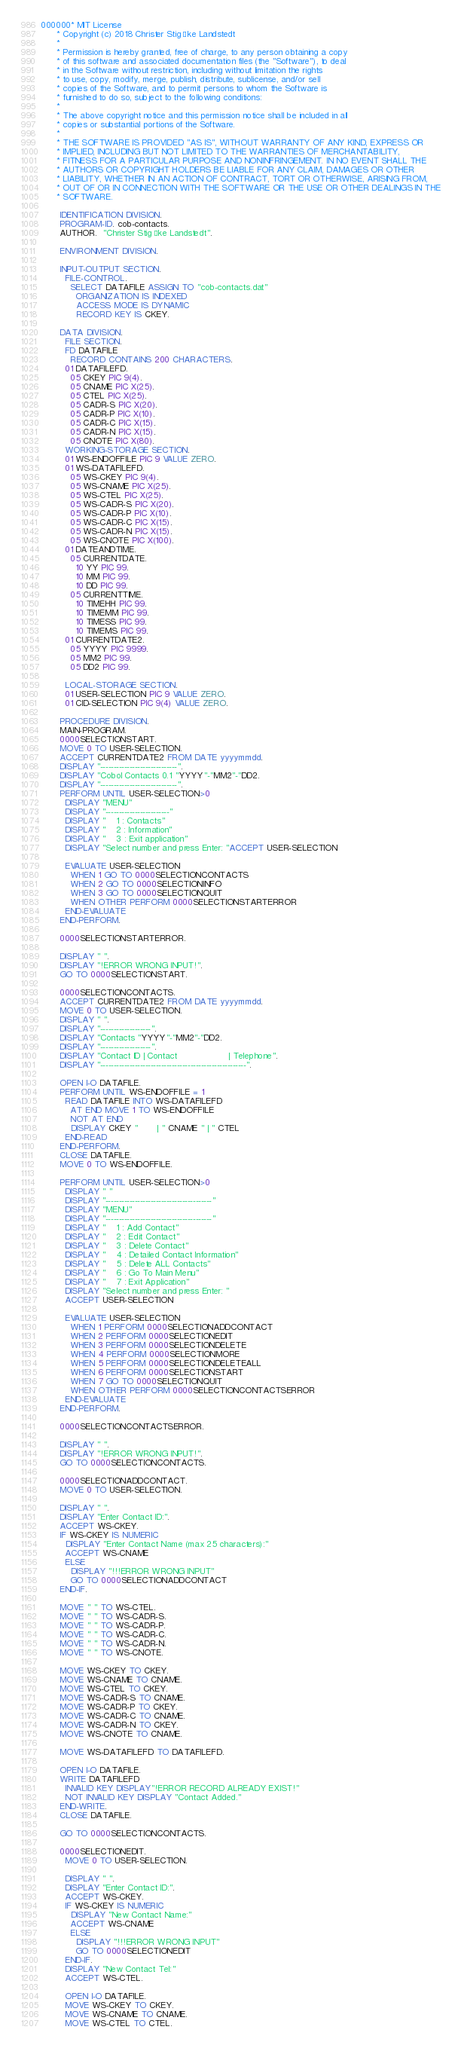Convert code to text. <code><loc_0><loc_0><loc_500><loc_500><_COBOL_>000000* MIT License
      * Copyright (c) 2018 Christer Stig Åke Landstedt
      * 
      * Permission is hereby granted, free of charge, to any person obtaining a copy
      * of this software and associated documentation files (the "Software"), to deal
      * in the Software without restriction, including without limitation the rights
      * to use, copy, modify, merge, publish, distribute, sublicense, and/or sell
      * copies of the Software, and to permit persons to whom the Software is
      * furnished to do so, subject to the following conditions:
      * 
      * The above copyright notice and this permission notice shall be included in all
      * copies or substantial portions of the Software.
      * 
      * THE SOFTWARE IS PROVIDED "AS IS", WITHOUT WARRANTY OF ANY KIND, EXPRESS OR
      * IMPLIED, INCLUDING BUT NOT LIMITED TO THE WARRANTIES OF MERCHANTABILITY,
      * FITNESS FOR A PARTICULAR PURPOSE AND NONINFRINGEMENT. IN NO EVENT SHALL THE
      * AUTHORS OR COPYRIGHT HOLDERS BE LIABLE FOR ANY CLAIM, DAMAGES OR OTHER
      * LIABILITY, WHETHER IN AN ACTION OF CONTRACT, TORT OR OTHERWISE, ARISING FROM,
      * OUT OF OR IN CONNECTION WITH THE SOFTWARE OR THE USE OR OTHER DEALINGS IN THE
      * SOFTWARE.
       
       IDENTIFICATION DIVISION.
       PROGRAM-ID. cob-contacts.
       AUTHOR.  "Christer Stig Åke Landstedt".

       ENVIRONMENT DIVISION.
       
       INPUT-OUTPUT SECTION.
         FILE-CONTROL.
           SELECT DATAFILE ASSIGN TO "cob-contacts.dat"
             ORGANIZATION IS INDEXED
             ACCESS MODE IS DYNAMIC
             RECORD KEY IS CKEY.
       
       DATA DIVISION.
         FILE SECTION.
         FD DATAFILE
           RECORD CONTAINS 200 CHARACTERS.
         01 DATAFILEFD.
           05 CKEY PIC 9(4).
           05 CNAME PIC X(25).
           05 CTEL PIC X(25).
           05 CADR-S PIC X(20).
           05 CADR-P PIC X(10).
           05 CADR-C PIC X(15).
           05 CADR-N PIC X(15).
           05 CNOTE PIC X(80).
         WORKING-STORAGE SECTION.
         01 WS-ENDOFFILE PIC 9 VALUE ZERO. 
         01 WS-DATAFILEFD.
           05 WS-CKEY PIC 9(4).
           05 WS-CNAME PIC X(25).
           05 WS-CTEL PIC X(25).
           05 WS-CADR-S PIC X(20).
           05 WS-CADR-P PIC X(10).
           05 WS-CADR-C PIC X(15).
           05 WS-CADR-N PIC X(15).
           05 WS-CNOTE PIC X(100).
         01 DATEANDTIME.
           05 CURRENTDATE.
             10 YY PIC 99.
             10 MM PIC 99.
             10 DD PIC 99.
           05 CURRENTTIME.
             10 TIMEHH PIC 99.
             10 TIMEMM PIC 99.
             10 TIMESS PIC 99.
             10 TIMEMS PIC 99.
         01 CURRENTDATE2.
           05 YYYY PIC 9999.
           05 MM2 PIC 99.
           05 DD2 PIC 99.

         LOCAL-STORAGE SECTION.
         01 USER-SELECTION PIC 9 VALUE ZERO.
         01 CID-SELECTION PIC 9(4) VALUE ZERO.

       PROCEDURE DIVISION.
       MAIN-PROGRAM.
       0000SELECTIONSTART.
       MOVE 0 TO USER-SELECTION.
       ACCEPT CURRENTDATE2 FROM DATE yyyymmdd.
       DISPLAY "-----------------------------".
       DISPLAY "Cobol Contacts 0.1 "YYYY"-"MM2"-"DD2.
       DISPLAY "-----------------------------".
       PERFORM UNTIL USER-SELECTION>0
         DISPLAY "MENU"
         DISPLAY "------------------------"
         DISPLAY "    1 : Contacts"
         DISPLAY "    2 : Information"
         DISPLAY "    3 : Exit application"
         DISPLAY "Select number and press Enter: "ACCEPT USER-SELECTION

         EVALUATE USER-SELECTION
           WHEN 1 GO TO 0000SELECTIONCONTACTS
           WHEN 2 GO TO 0000SELECTIONINFO
           WHEN 3 GO TO 0000SELECTIONQUIT
           WHEN OTHER PERFORM 0000SELECTIONSTARTERROR
         END-EVALUATE
       END-PERFORM.

       0000SELECTIONSTARTERROR.

       DISPLAY " ".
       DISPLAY "!ERROR WRONG INPUT!".
       GO TO 0000SELECTIONSTART.
       
       0000SELECTIONCONTACTS.
       ACCEPT CURRENTDATE2 FROM DATE yyyymmdd.
       MOVE 0 TO USER-SELECTION.
       DISPLAY " ".
       DISPLAY "-------------------".
       DISPLAY "Contacts "YYYY"-"MM2"-"DD2.
       DISPLAY "-------------------".
       DISPLAY "Contact ID | Contact                   | Telephone".
       DISPLAY "-------------------------------------------------------".

       OPEN I-O DATAFILE.
       PERFORM UNTIL WS-ENDOFFILE = 1
         READ DATAFILE INTO WS-DATAFILEFD
           AT END MOVE 1 TO WS-ENDOFFILE
           NOT AT END
           DISPLAY CKEY "       | " CNAME " | " CTEL
         END-READ    
       END-PERFORM.
       CLOSE DATAFILE.
       MOVE 0 TO WS-ENDOFFILE.

       PERFORM UNTIL USER-SELECTION>0
         DISPLAY " "
         DISPLAY "----------------------------------------"
         DISPLAY "MENU"
         DISPLAY "----------------------------------------"
         DISPLAY "    1 : Add Contact"
         DISPLAY "    2 : Edit Contact"
         DISPLAY "    3 : Delete Contact"
         DISPLAY "    4 : Detailed Contact Information"
         DISPLAY "    5 : Delete ALL Contacts"
         DISPLAY "    6 : Go To Main Menu"
         DISPLAY "    7 : Exit Application"
         DISPLAY "Select number and press Enter: "
         ACCEPT USER-SELECTION

         EVALUATE USER-SELECTION
           WHEN 1 PERFORM 0000SELECTIONADDCONTACT
           WHEN 2 PERFORM 0000SELECTIONEDIT
           WHEN 3 PERFORM 0000SELECTIONDELETE
           WHEN 4 PERFORM 0000SELECTIONMORE
           WHEN 5 PERFORM 0000SELECTIONDELETEALL
           WHEN 6 PERFORM 0000SELECTIONSTART
           WHEN 7 GO TO 0000SELECTIONQUIT
           WHEN OTHER PERFORM 0000SELECTIONCONTACTSERROR
         END-EVALUATE
       END-PERFORM.

       0000SELECTIONCONTACTSERROR.

       DISPLAY " ".
       DISPLAY "!ERROR WRONG INPUT!".
       GO TO 0000SELECTIONCONTACTS.

       0000SELECTIONADDCONTACT.
       MOVE 0 TO USER-SELECTION.

       DISPLAY " ".
       DISPLAY "Enter Contact ID:".
       ACCEPT WS-CKEY.
       IF WS-CKEY IS NUMERIC
         DISPLAY "Enter Contact Name (max 25 characters):"
         ACCEPT WS-CNAME
         ELSE
           DISPLAY "!!!ERROR WRONG INPUT"
           GO TO 0000SELECTIONADDCONTACT
       END-IF.

       MOVE " " TO WS-CTEL.
       MOVE " " TO WS-CADR-S.
       MOVE " " TO WS-CADR-P.
       MOVE " " TO WS-CADR-C.
       MOVE " " TO WS-CADR-N.
       MOVE " " TO WS-CNOTE.

       MOVE WS-CKEY TO CKEY.
       MOVE WS-CNAME TO CNAME.
       MOVE WS-CTEL TO CKEY.
       MOVE WS-CADR-S TO CNAME.
       MOVE WS-CADR-P TO CKEY.
       MOVE WS-CADR-C TO CNAME.
       MOVE WS-CADR-N TO CKEY.
       MOVE WS-CNOTE TO CNAME.

       MOVE WS-DATAFILEFD TO DATAFILEFD.

       OPEN I-O DATAFILE.
       WRITE DATAFILEFD
         INVALID KEY DISPLAY"!ERROR RECORD ALREADY EXIST!"
         NOT INVALID KEY DISPLAY "Contact Added."
       END-WRITE.
       CLOSE DATAFILE.

       GO TO 0000SELECTIONCONTACTS.

       0000SELECTIONEDIT.
         MOVE 0 TO USER-SELECTION.

         DISPLAY " ".
         DISPLAY "Enter Contact ID:".
         ACCEPT WS-CKEY.
         IF WS-CKEY IS NUMERIC
           DISPLAY "New Contact Name:"
           ACCEPT WS-CNAME
           ELSE
             DISPLAY "!!!ERROR WRONG INPUT"
             GO TO 0000SELECTIONEDIT
         END-IF.
         DISPLAY "New Contact Tel:"
         ACCEPT WS-CTEL.

         OPEN I-O DATAFILE.
         MOVE WS-CKEY TO CKEY.
         MOVE WS-CNAME TO CNAME.
         MOVE WS-CTEL TO CTEL.</code> 